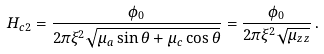<formula> <loc_0><loc_0><loc_500><loc_500>H _ { c 2 } = \frac { \phi _ { 0 } } { 2 \pi \xi ^ { 2 } \sqrt { \mu _ { a } \sin \theta + \mu _ { c } \cos \theta } } = \frac { \phi _ { 0 } } { 2 \pi \xi ^ { 2 } \sqrt { \mu _ { z z } } } \, .</formula> 